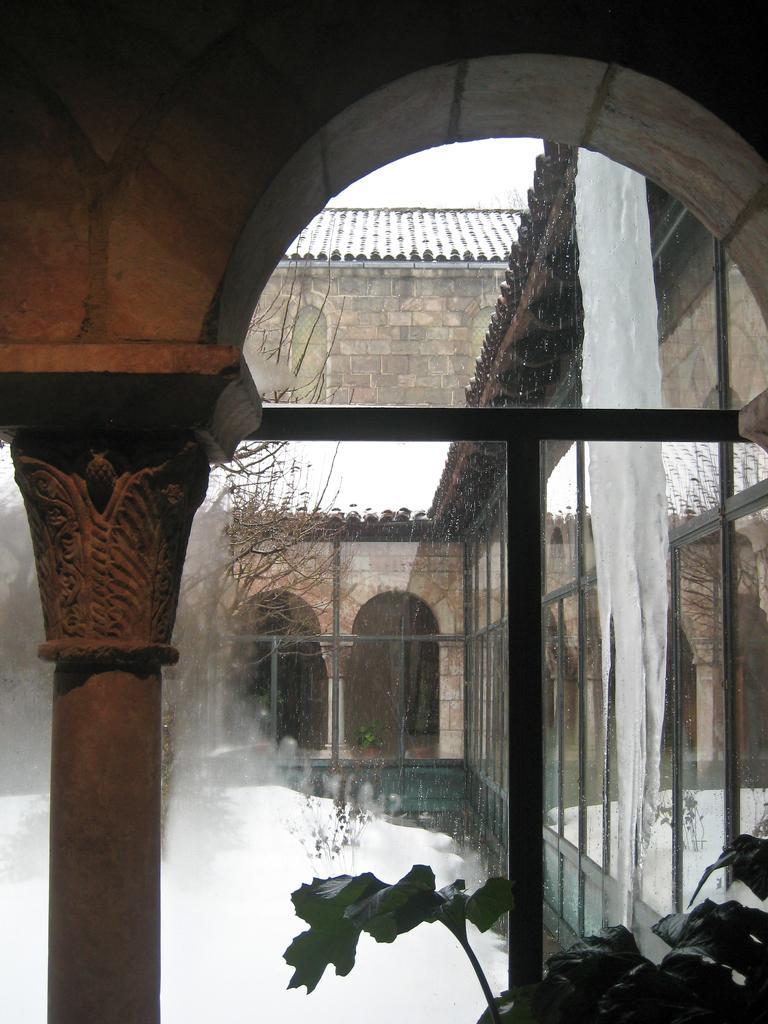Please provide a concise description of this image. In this picture we can see a building. On the left there is a tree. On the bottom right corner we can see a plant. Here we can see snow. Here it's a sky. 